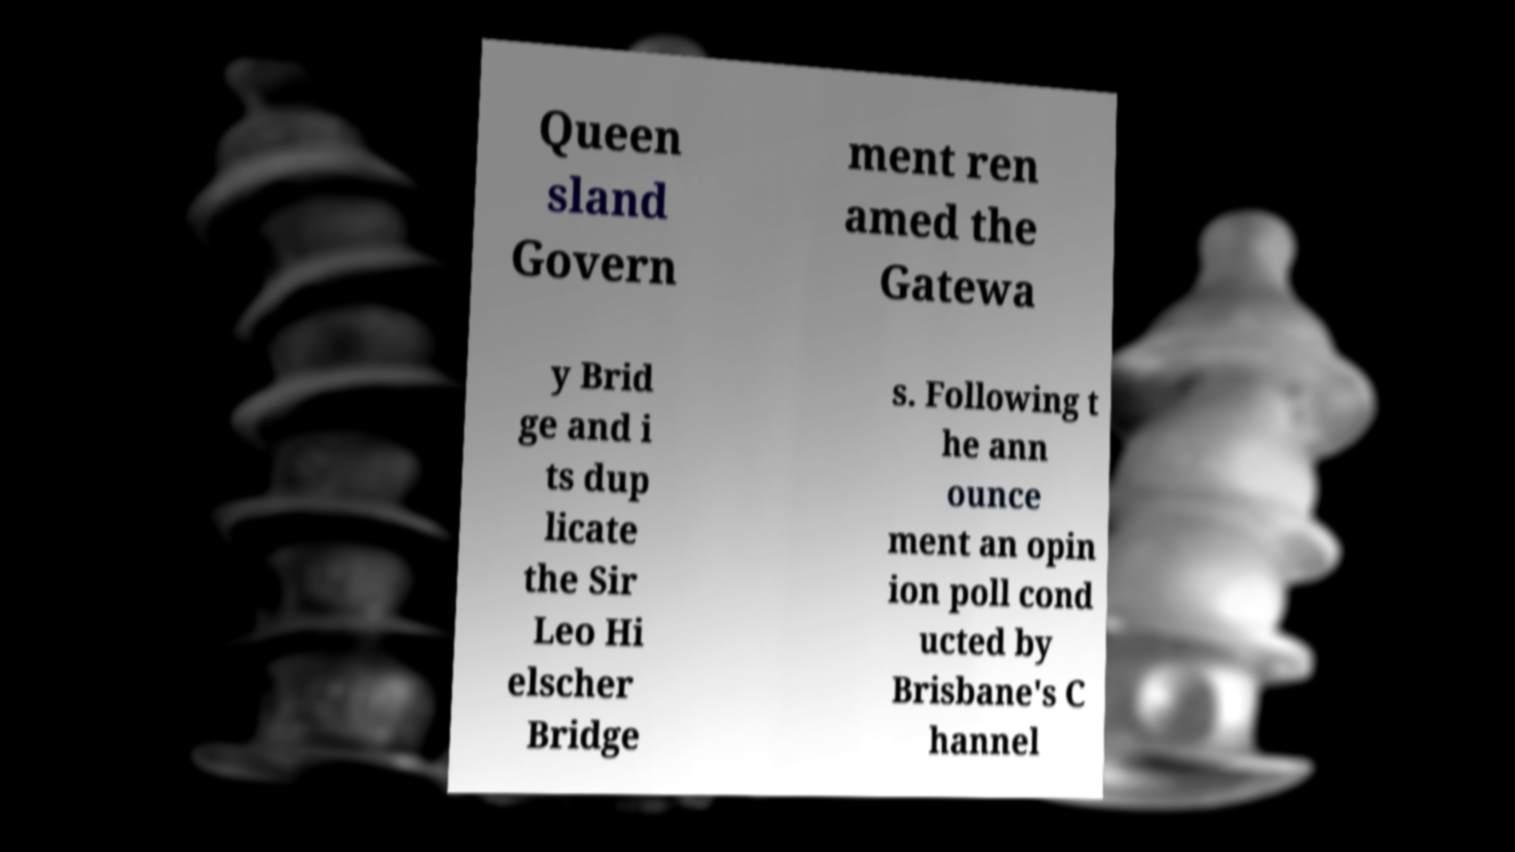Can you accurately transcribe the text from the provided image for me? Queen sland Govern ment ren amed the Gatewa y Brid ge and i ts dup licate the Sir Leo Hi elscher Bridge s. Following t he ann ounce ment an opin ion poll cond ucted by Brisbane's C hannel 